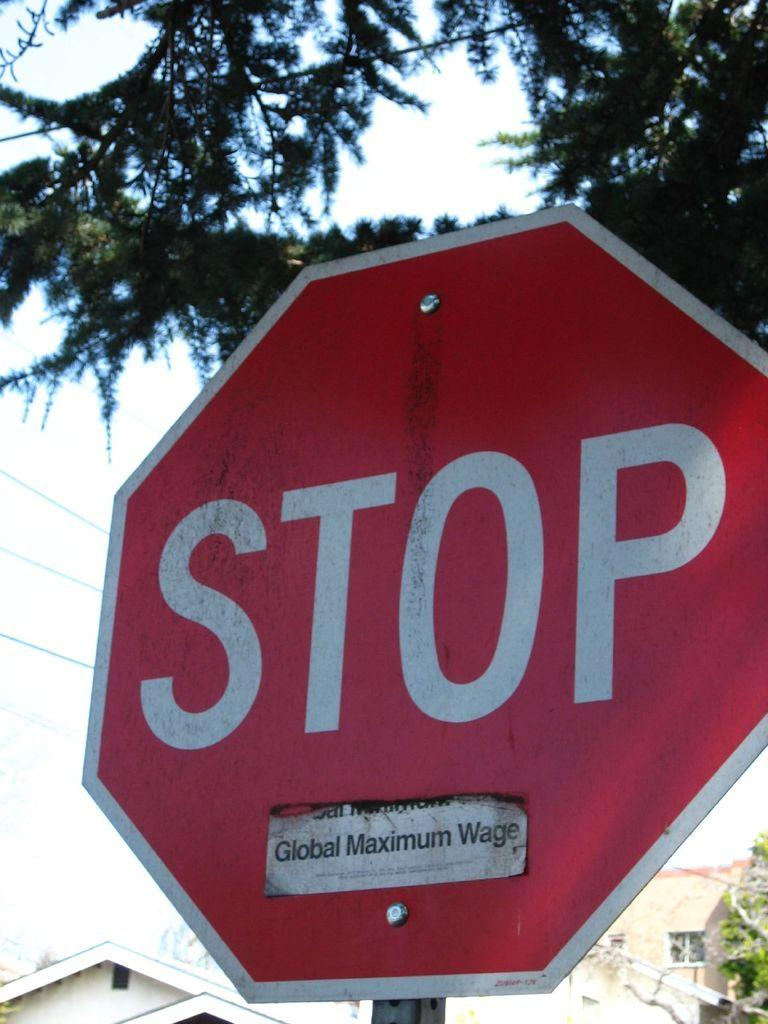<image>
Share a concise interpretation of the image provided. red stop sign with a sticker placed on the bottom 